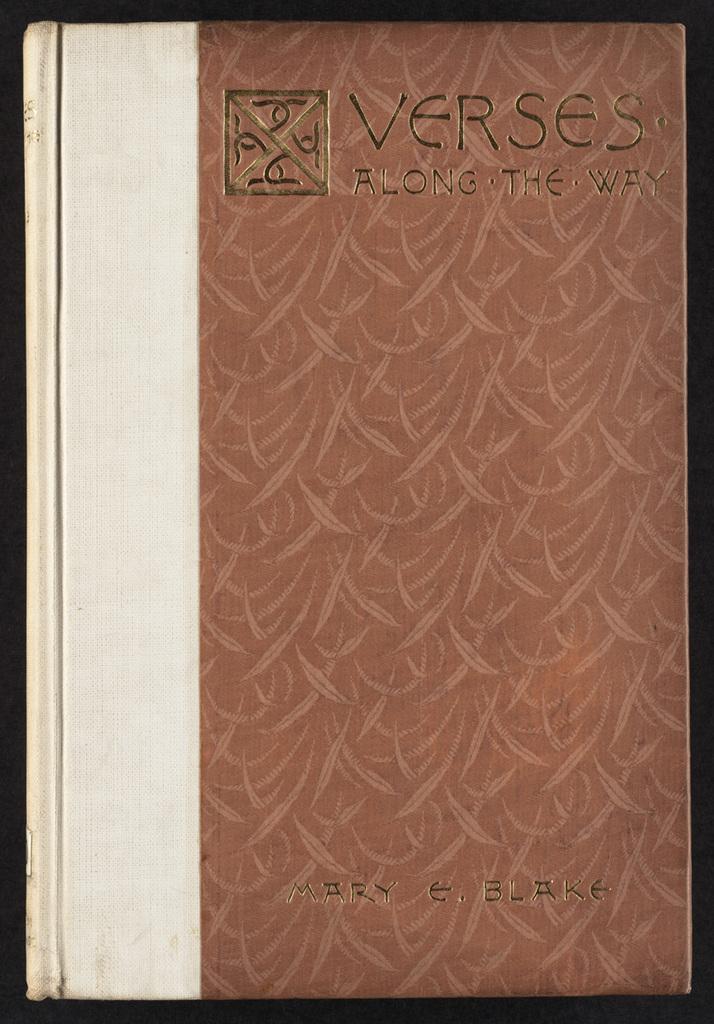Who is the author of this book?
Make the answer very short. Mary e. blake. What is the title?
Make the answer very short. Verses along the way. 